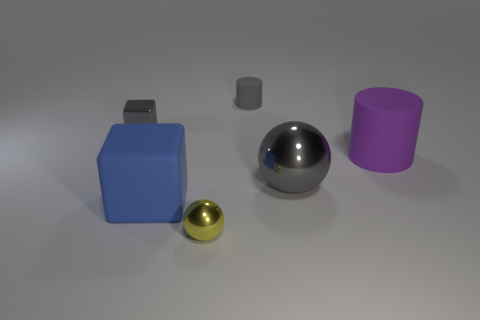There is a matte cube that is the same size as the gray metal sphere; what is its color?
Your answer should be very brief. Blue. Is there a metal thing of the same color as the tiny block?
Give a very brief answer. Yes. Is the number of gray matte cylinders in front of the big metal object less than the number of blue things right of the large matte cube?
Offer a very short reply. No. What is the material of the object that is to the left of the yellow sphere and behind the large blue matte thing?
Your answer should be compact. Metal. There is a big purple matte object; is it the same shape as the small gray thing that is on the right side of the gray block?
Ensure brevity in your answer.  Yes. What number of other objects are the same size as the gray metallic sphere?
Your response must be concise. 2. Is the number of blue matte things greater than the number of objects?
Provide a short and direct response. No. What number of objects are behind the large purple matte thing and left of the yellow metal sphere?
Make the answer very short. 1. The gray metal thing behind the gray object on the right side of the cylinder behind the large purple rubber cylinder is what shape?
Provide a succinct answer. Cube. What number of cylinders are gray matte objects or blue things?
Your answer should be compact. 1. 